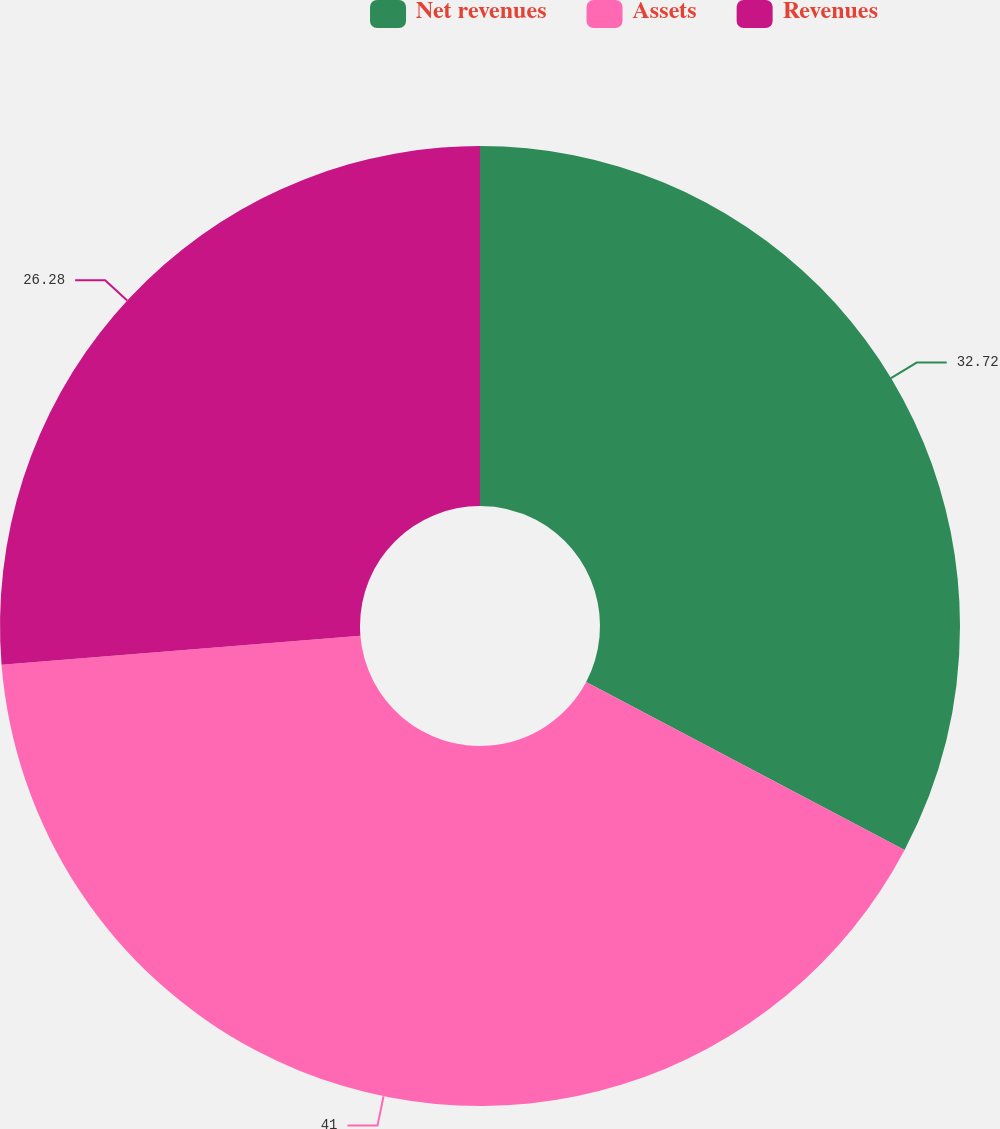<chart> <loc_0><loc_0><loc_500><loc_500><pie_chart><fcel>Net revenues<fcel>Assets<fcel>Revenues<nl><fcel>32.72%<fcel>40.99%<fcel>26.28%<nl></chart> 